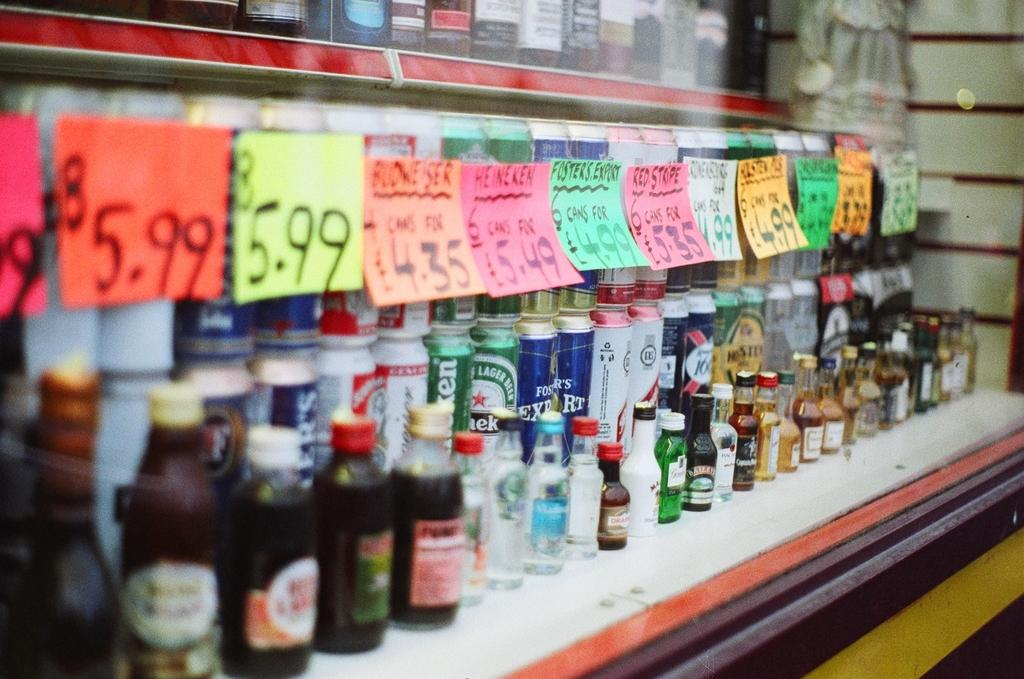<image>
Write a terse but informative summary of the picture. A row of cans of beer including Budweiser, Heiniken, and Fosters. 